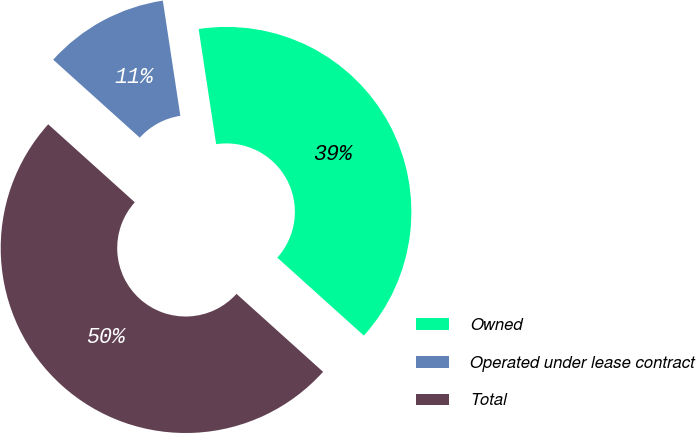Convert chart to OTSL. <chart><loc_0><loc_0><loc_500><loc_500><pie_chart><fcel>Owned<fcel>Operated under lease contract<fcel>Total<nl><fcel>39.07%<fcel>10.93%<fcel>50.0%<nl></chart> 